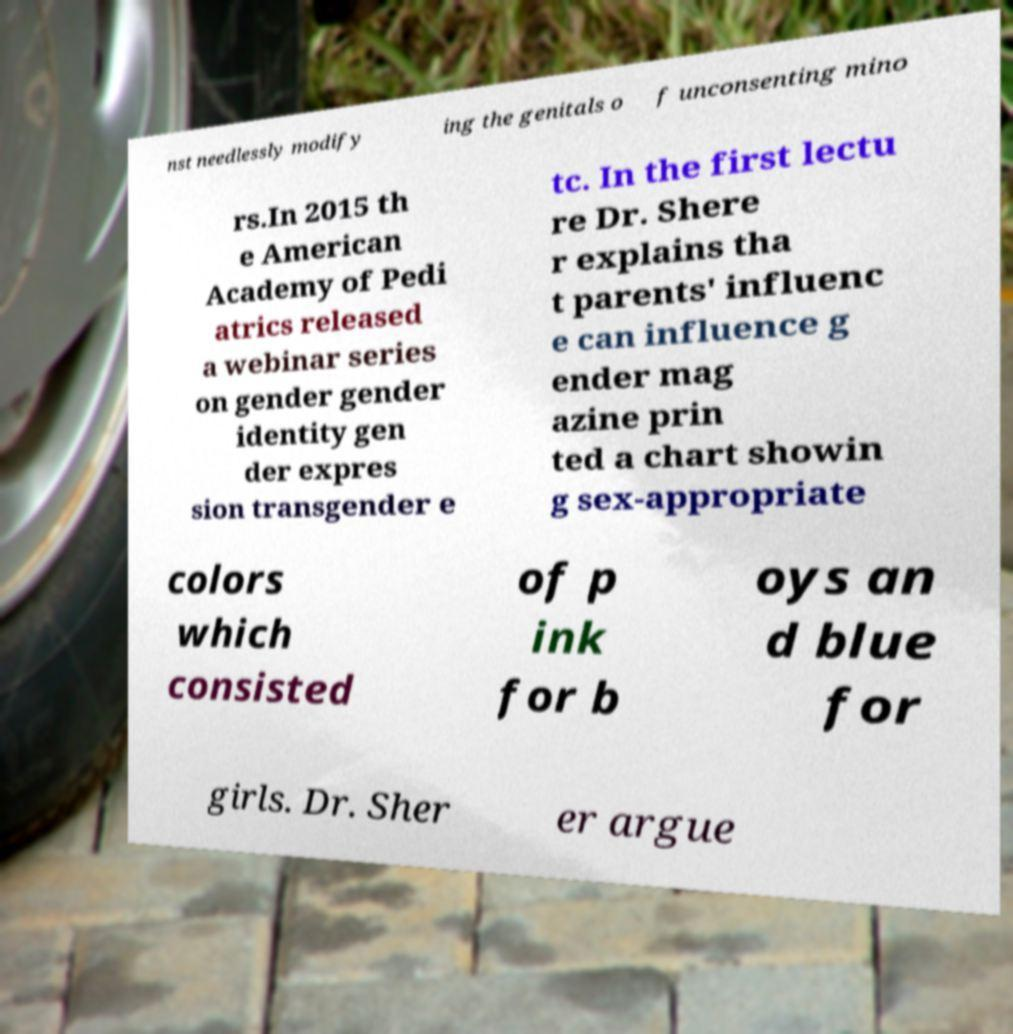Please identify and transcribe the text found in this image. nst needlessly modify ing the genitals o f unconsenting mino rs.In 2015 th e American Academy of Pedi atrics released a webinar series on gender gender identity gen der expres sion transgender e tc. In the first lectu re Dr. Shere r explains tha t parents' influenc e can influence g ender mag azine prin ted a chart showin g sex-appropriate colors which consisted of p ink for b oys an d blue for girls. Dr. Sher er argue 